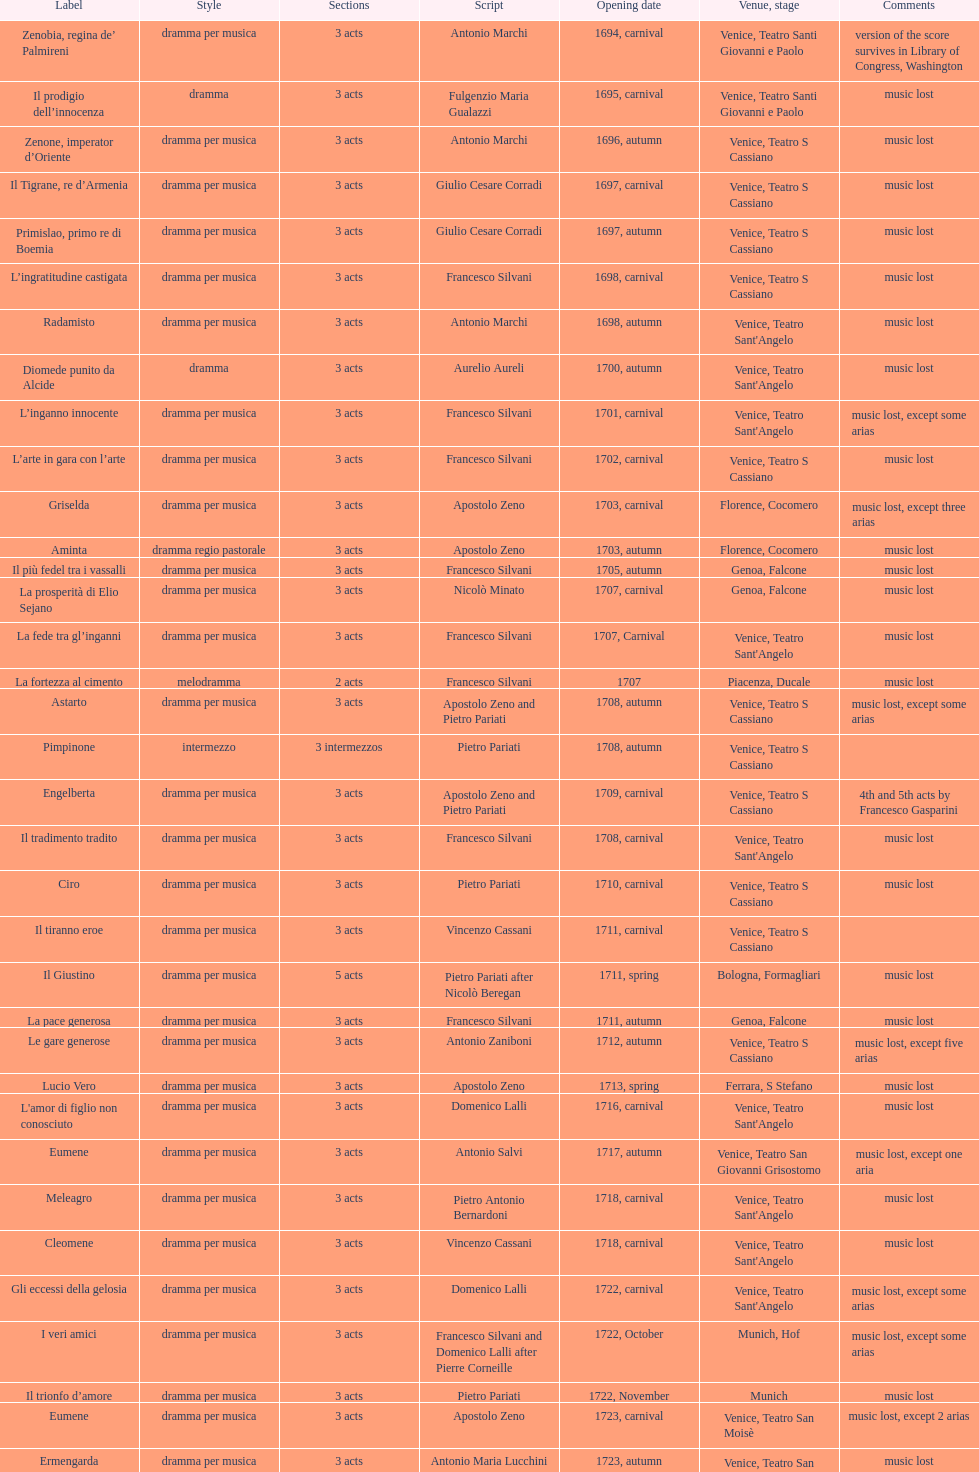How many were released after zenone, imperator d'oriente? 52. 